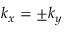<formula> <loc_0><loc_0><loc_500><loc_500>k _ { x } = \pm k _ { y }</formula> 